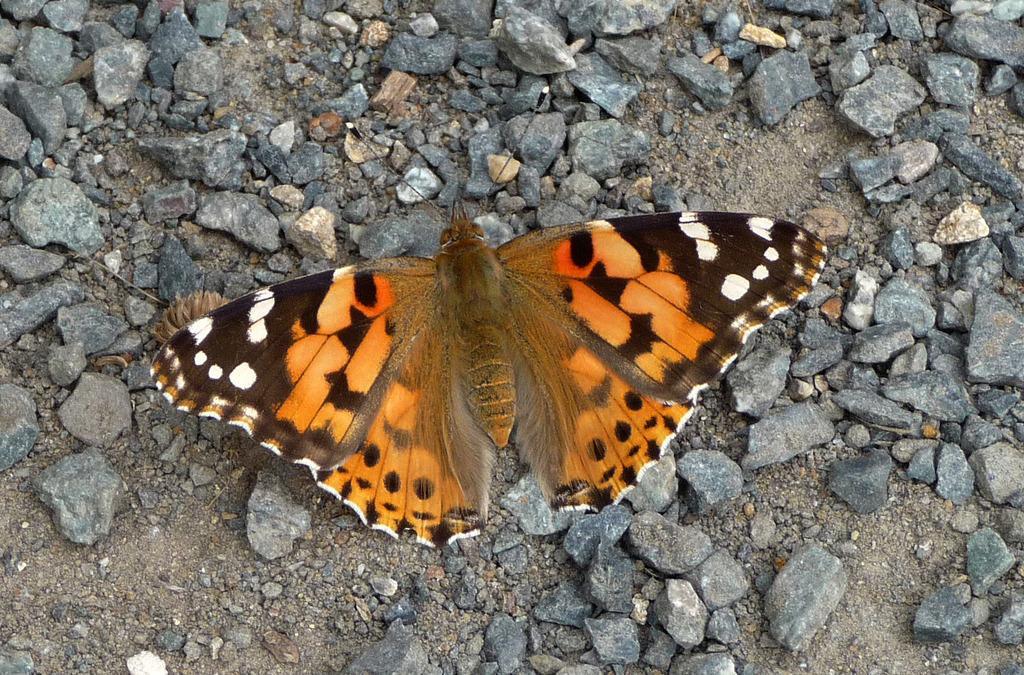How would you summarize this image in a sentence or two? In this image I can see a butterfly which is in brown, orange, white and black in color. To the side I can see many stones. 